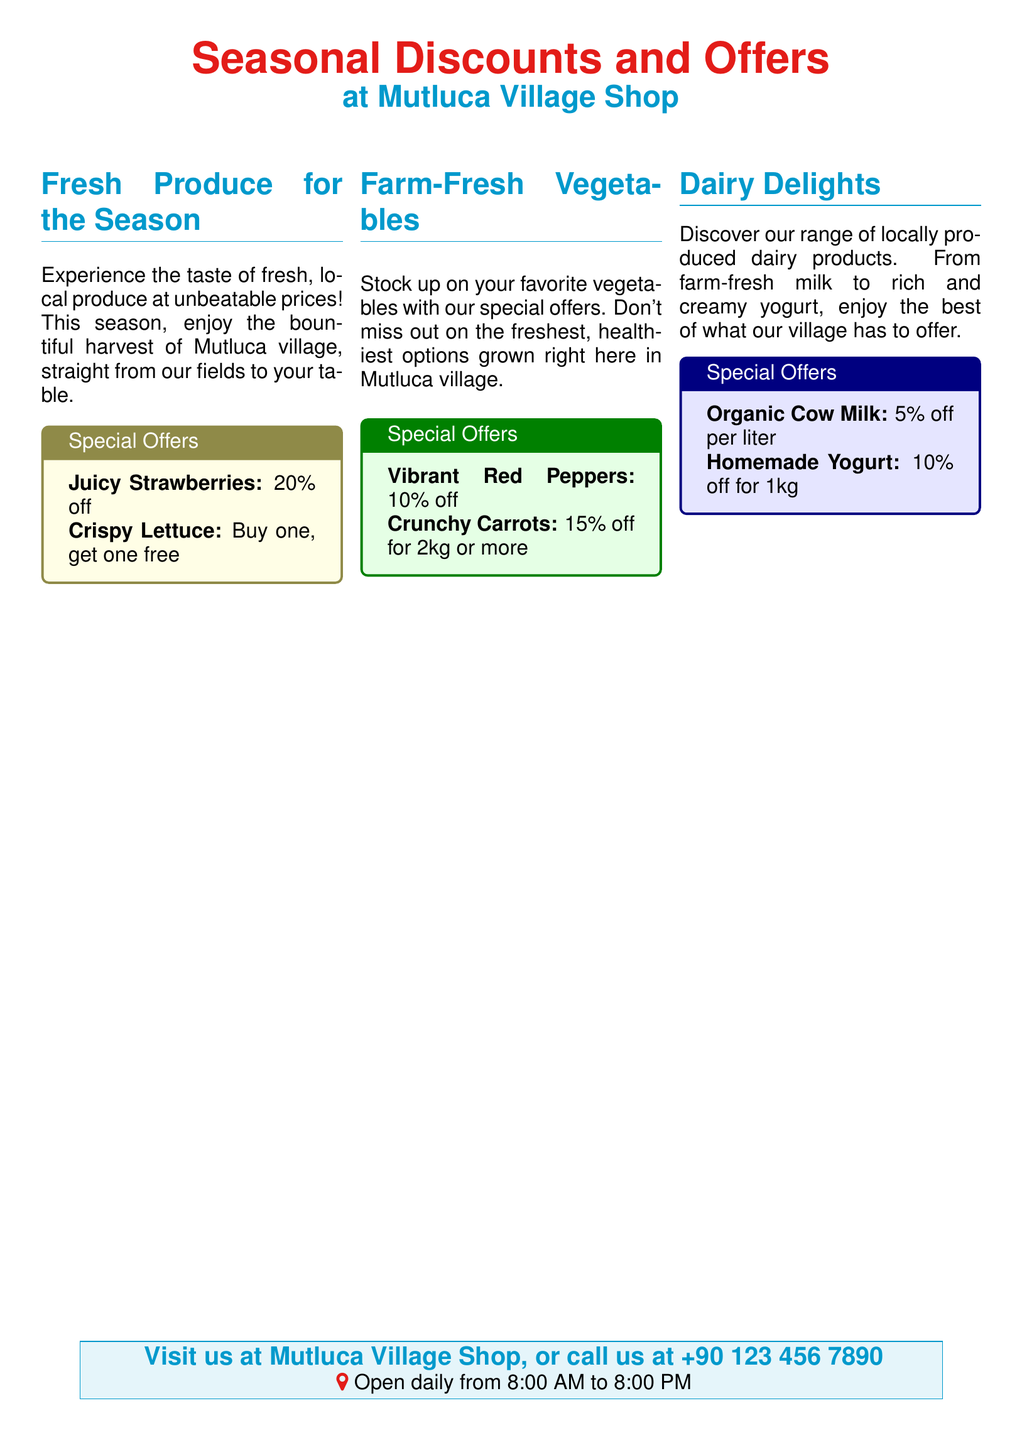What discounts are available for strawberries? The document specifies a 20% discount for strawberries.
Answer: 20% off What is the offer for lettuce? The document states the offer for lettuce is a buy one, get one free.
Answer: Buy one, get one free What is the discount for organic cow milk? The document mentions a 5% discount per liter for organic cow milk.
Answer: 5% off per liter What is the selling price for crunchy carrots from the document? The document states a 15% discount for purchasing 2kg or more of crunchy carrots.
Answer: 15% off for 2kg or more What time does the shop open? The document notes that the shop opens daily at 8:00 AM.
Answer: 8:00 AM What is the total discount on homemade yogurt if buying 1kg? The document specifies a 10% discount on homemade yogurt for 1kg.
Answer: 10% off for 1kg Which item has a discount of 10%? The document lists vibrant red peppers as having a 10% discount.
Answer: Vibrant Red Peppers Where can customers find the Mutluca Village Shop? The document indicates that customers can visit the Mutluca Village Shop.
Answer: At Mutluca Village Shop What are the operating hours mentioned in the document? The document states the shop operates from 8:00 AM to 8:00 PM.
Answer: 8:00 AM to 8:00 PM 